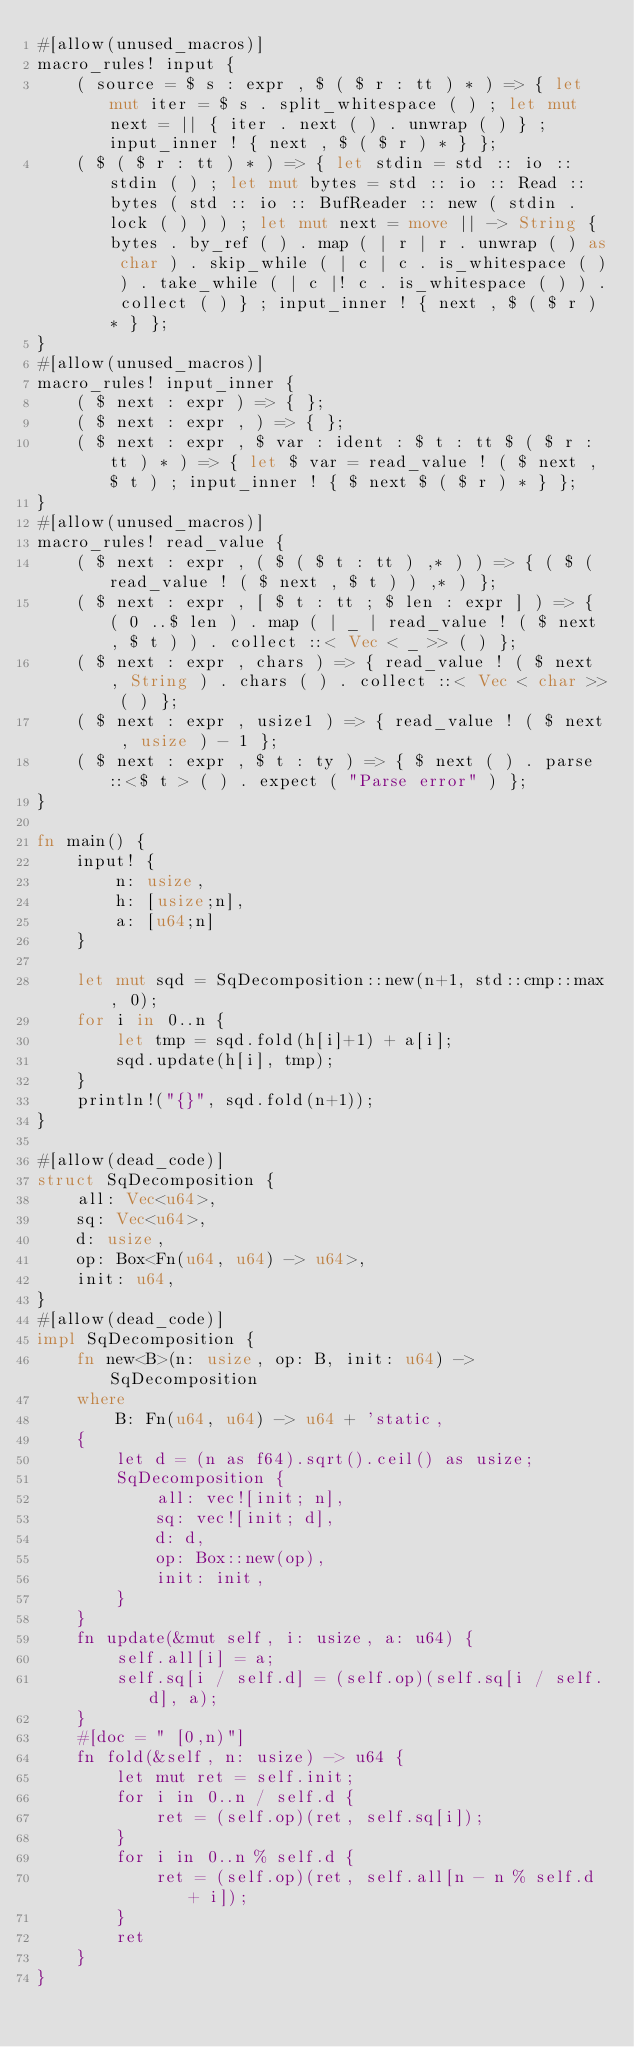Convert code to text. <code><loc_0><loc_0><loc_500><loc_500><_Rust_>#[allow(unused_macros)]
macro_rules! input {
    ( source = $ s : expr , $ ( $ r : tt ) * ) => { let mut iter = $ s . split_whitespace ( ) ; let mut next = || { iter . next ( ) . unwrap ( ) } ; input_inner ! { next , $ ( $ r ) * } };
    ( $ ( $ r : tt ) * ) => { let stdin = std :: io :: stdin ( ) ; let mut bytes = std :: io :: Read :: bytes ( std :: io :: BufReader :: new ( stdin . lock ( ) ) ) ; let mut next = move || -> String { bytes . by_ref ( ) . map ( | r | r . unwrap ( ) as char ) . skip_while ( | c | c . is_whitespace ( ) ) . take_while ( | c |! c . is_whitespace ( ) ) . collect ( ) } ; input_inner ! { next , $ ( $ r ) * } };
}
#[allow(unused_macros)]
macro_rules! input_inner {
    ( $ next : expr ) => { };
    ( $ next : expr , ) => { };
    ( $ next : expr , $ var : ident : $ t : tt $ ( $ r : tt ) * ) => { let $ var = read_value ! ( $ next , $ t ) ; input_inner ! { $ next $ ( $ r ) * } };
}
#[allow(unused_macros)]
macro_rules! read_value {
    ( $ next : expr , ( $ ( $ t : tt ) ,* ) ) => { ( $ ( read_value ! ( $ next , $ t ) ) ,* ) };
    ( $ next : expr , [ $ t : tt ; $ len : expr ] ) => { ( 0 ..$ len ) . map ( | _ | read_value ! ( $ next , $ t ) ) . collect ::< Vec < _ >> ( ) };
    ( $ next : expr , chars ) => { read_value ! ( $ next , String ) . chars ( ) . collect ::< Vec < char >> ( ) };
    ( $ next : expr , usize1 ) => { read_value ! ( $ next , usize ) - 1 };
    ( $ next : expr , $ t : ty ) => { $ next ( ) . parse ::<$ t > ( ) . expect ( "Parse error" ) };
}

fn main() {
    input! {
        n: usize,
        h: [usize;n],
        a: [u64;n]
    }

    let mut sqd = SqDecomposition::new(n+1, std::cmp::max, 0);
    for i in 0..n {
        let tmp = sqd.fold(h[i]+1) + a[i];
        sqd.update(h[i], tmp);
    }
    println!("{}", sqd.fold(n+1));
}

#[allow(dead_code)]
struct SqDecomposition {
    all: Vec<u64>,
    sq: Vec<u64>,
    d: usize,
    op: Box<Fn(u64, u64) -> u64>,
    init: u64,
}
#[allow(dead_code)]
impl SqDecomposition {
    fn new<B>(n: usize, op: B, init: u64) -> SqDecomposition
    where
        B: Fn(u64, u64) -> u64 + 'static,
    {
        let d = (n as f64).sqrt().ceil() as usize;
        SqDecomposition {
            all: vec![init; n],
            sq: vec![init; d],
            d: d,
            op: Box::new(op),
            init: init,
        }
    }
    fn update(&mut self, i: usize, a: u64) {
        self.all[i] = a;
        self.sq[i / self.d] = (self.op)(self.sq[i / self.d], a);
    }
    #[doc = " [0,n)"]
    fn fold(&self, n: usize) -> u64 {
        let mut ret = self.init;
        for i in 0..n / self.d {
            ret = (self.op)(ret, self.sq[i]);
        }
        for i in 0..n % self.d {
            ret = (self.op)(ret, self.all[n - n % self.d + i]);
        }
        ret
    }
}</code> 